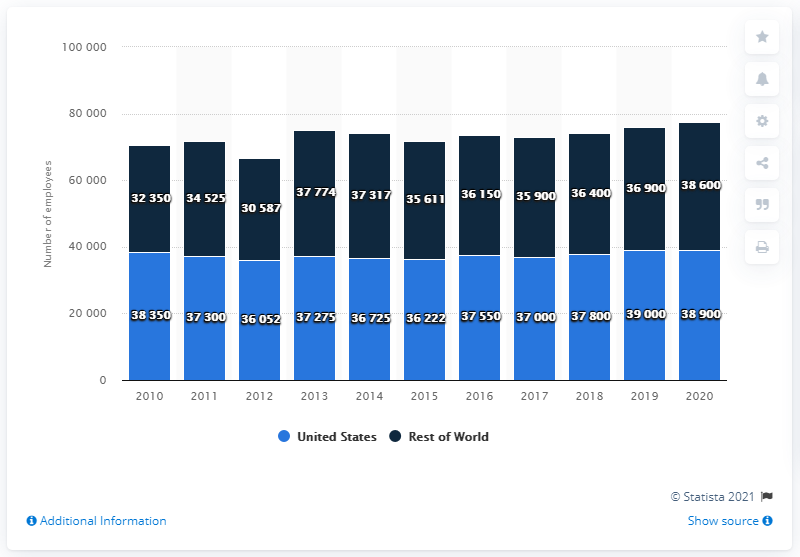Point out several critical features in this image. When the difference is taken between the longest dark blue bar and the longest light blue bar, the result is 400. In the year 2020, Cisco had the most number of employees all over the world. As of 2020, it is estimated that there were approximately 38,350 people who were employed in the rest of the world. 